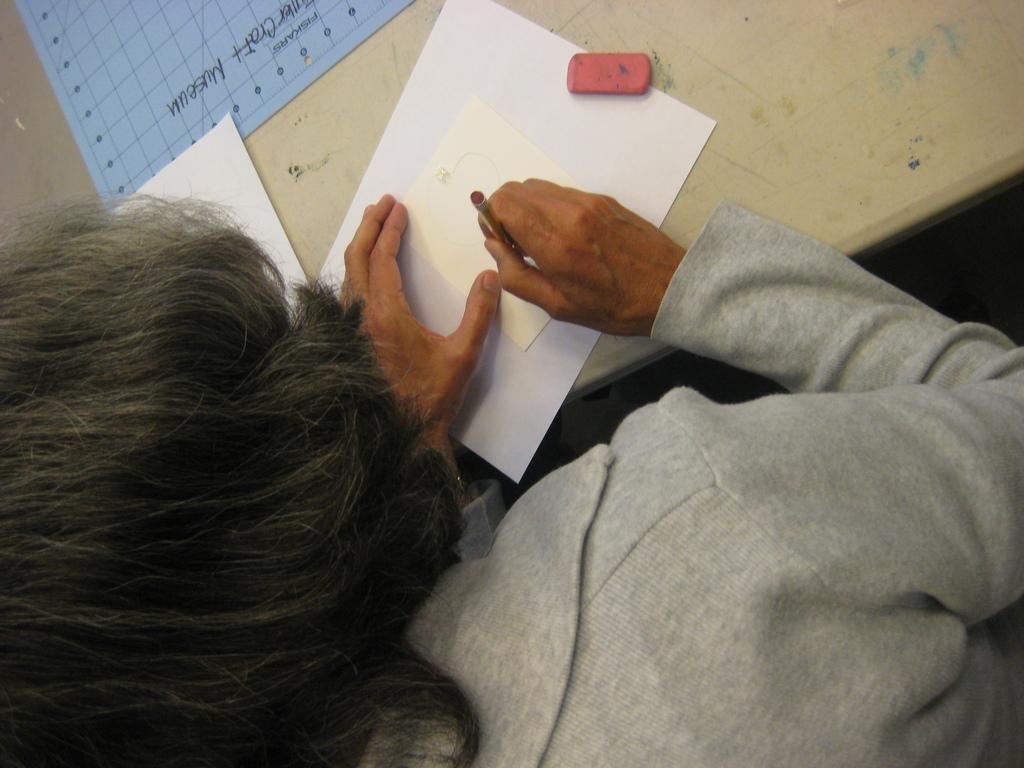Who is the main subject in the image? There is a lady in the image. What is the lady doing in the image? The lady is sitting on a chair. What is in front of the chair? There is a table in front of the chair. What is on the table? There are papers on the table. What type of can is visible on the table in the image? There is no can present on the table in the image; only papers are visible. 